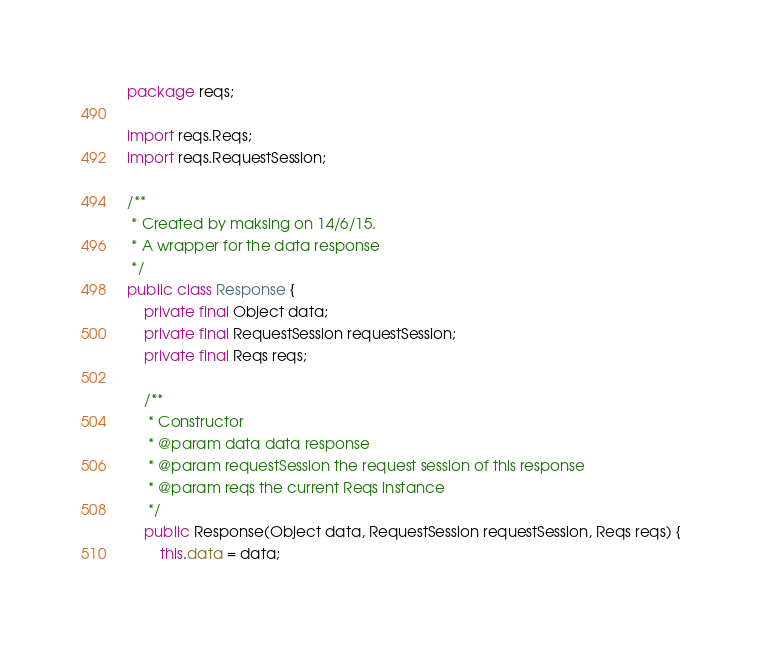<code> <loc_0><loc_0><loc_500><loc_500><_Java_>package reqs;

import reqs.Reqs;
import reqs.RequestSession;

/**
 * Created by maksing on 14/6/15.
 * A wrapper for the data response
 */
public class Response {
    private final Object data;
    private final RequestSession requestSession;
    private final Reqs reqs;

    /**
     * Constructor
     * @param data data response
     * @param requestSession the request session of this response
     * @param reqs the current Reqs instance
     */
    public Response(Object data, RequestSession requestSession, Reqs reqs) {
        this.data = data;</code> 